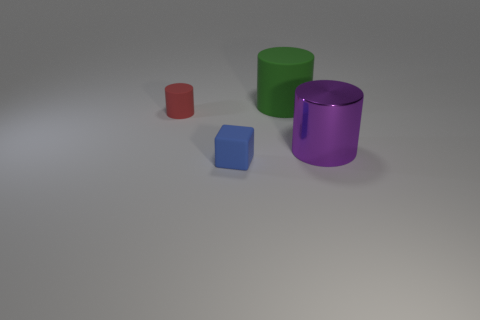What size is the matte thing that is left of the matte object in front of the cylinder right of the large matte thing?
Provide a succinct answer. Small. Is there anything else of the same color as the small cube?
Offer a terse response. No. There is a cylinder that is on the left side of the matte object that is right of the blue rubber block in front of the big purple cylinder; what is it made of?
Keep it short and to the point. Rubber. Does the large green object have the same shape as the blue object?
Offer a terse response. No. Is there anything else that is the same material as the purple cylinder?
Your answer should be compact. No. How many objects are both in front of the green object and behind the tiny blue thing?
Your answer should be compact. 2. There is a tiny object behind the object that is right of the green object; what color is it?
Offer a very short reply. Red. Are there an equal number of small matte blocks that are right of the tiny blue block and tiny blue rubber cylinders?
Provide a short and direct response. Yes. What number of red objects are on the right side of the large cylinder behind the cylinder that is on the right side of the large green cylinder?
Your response must be concise. 0. There is a large metallic object to the right of the small blue matte cube; what is its color?
Your answer should be very brief. Purple. 